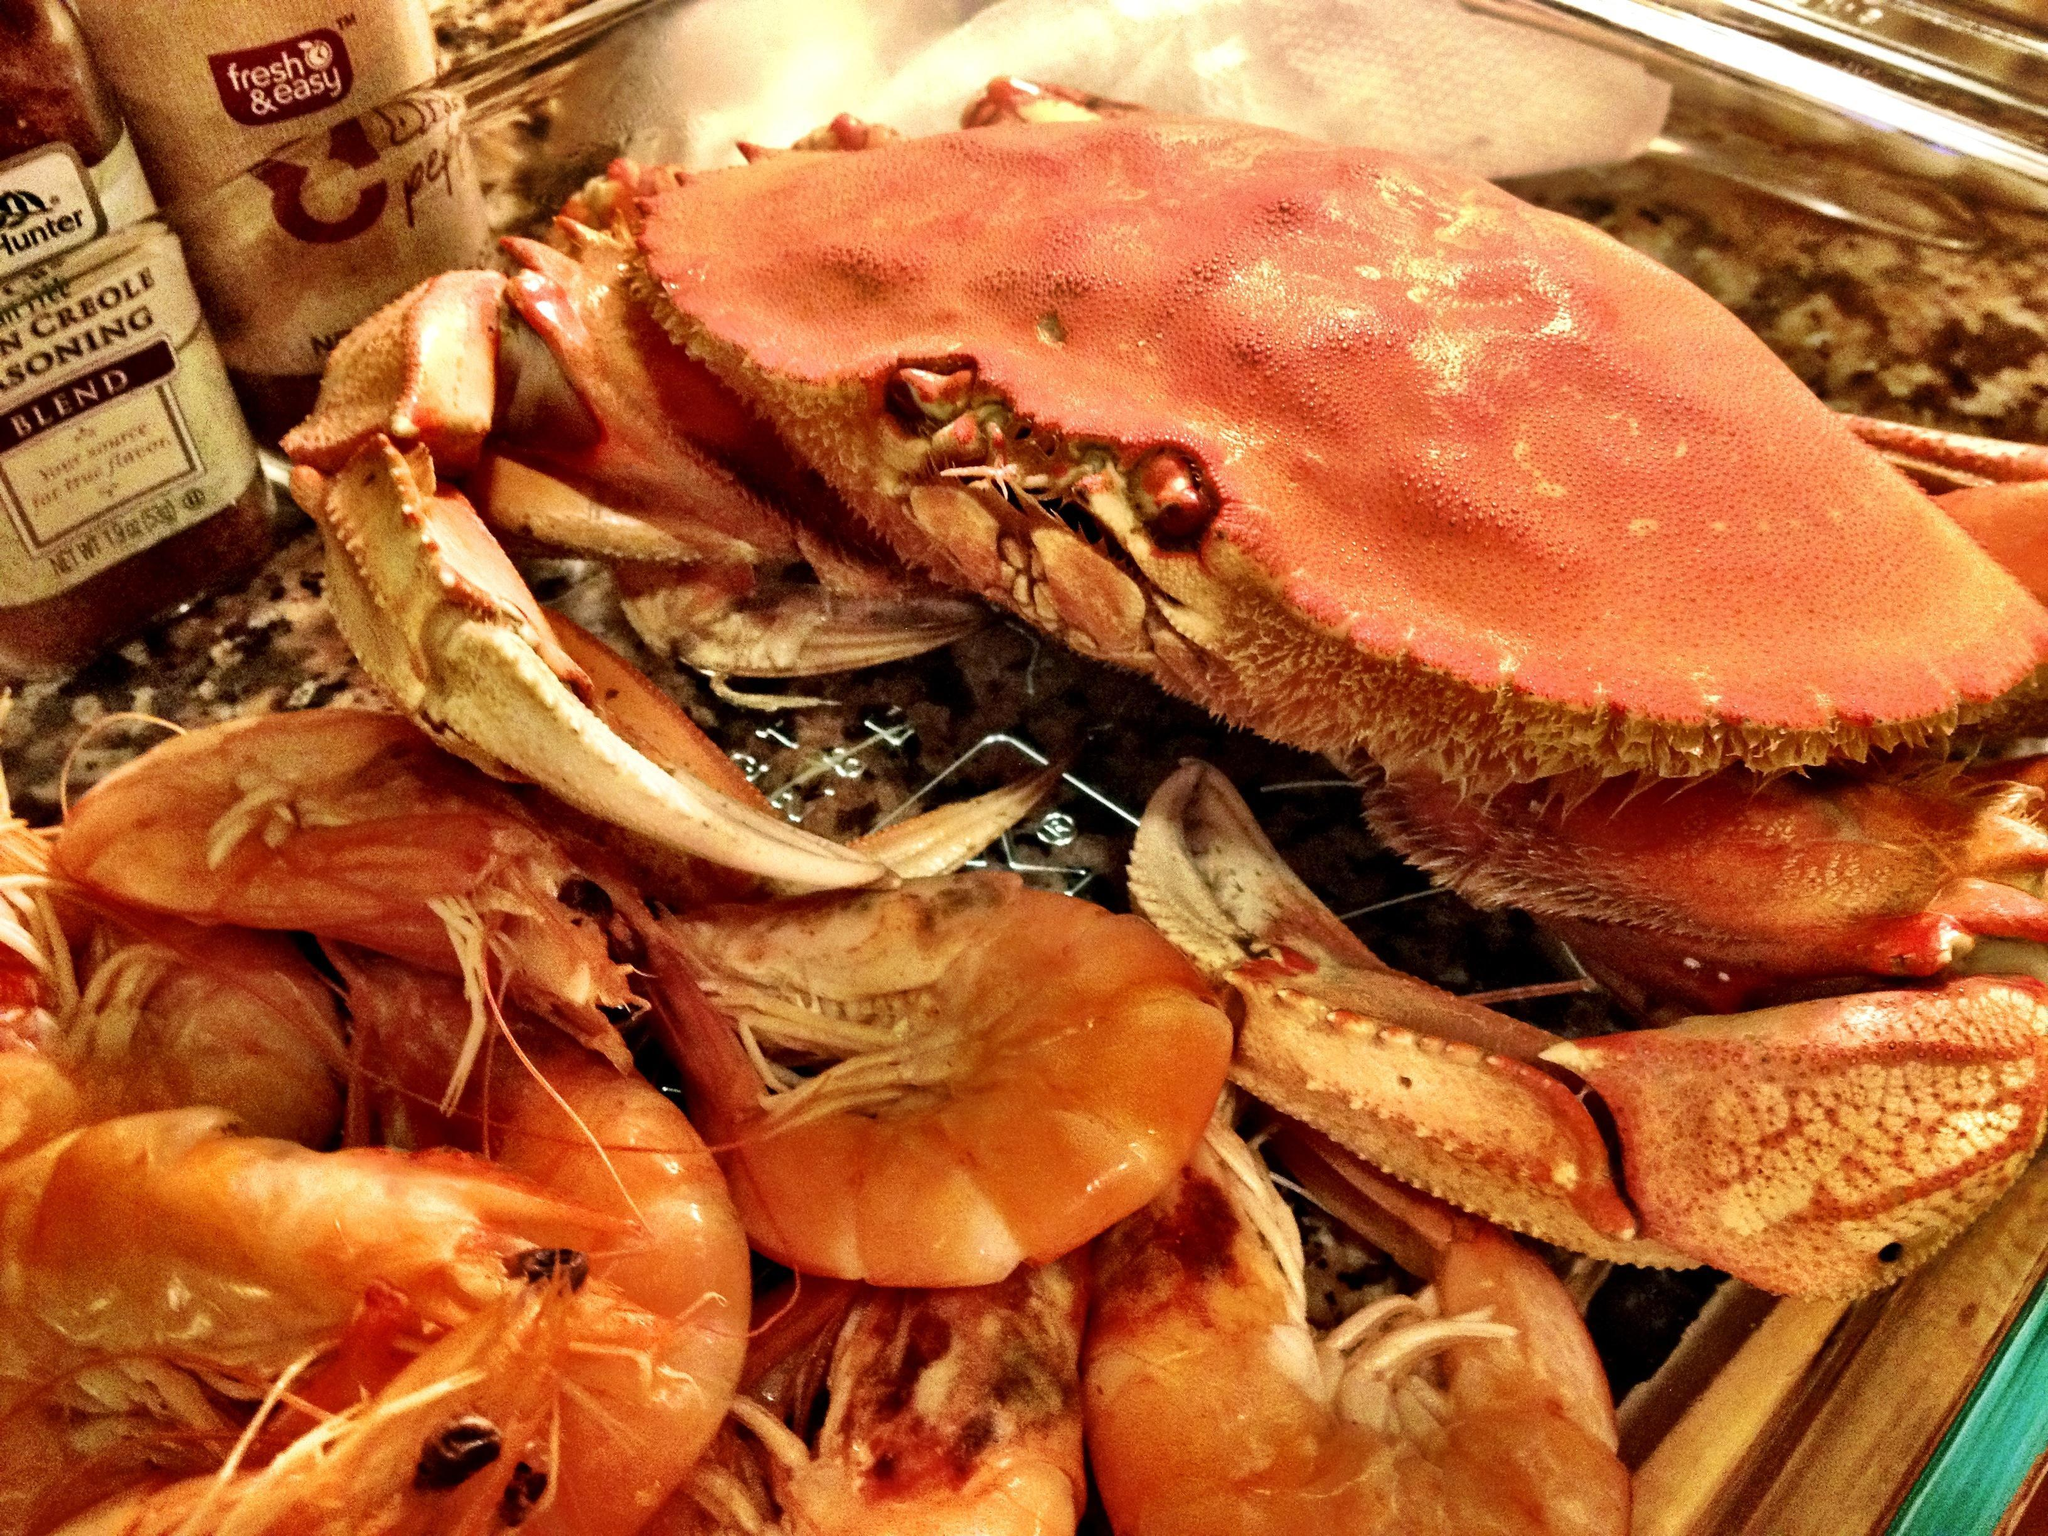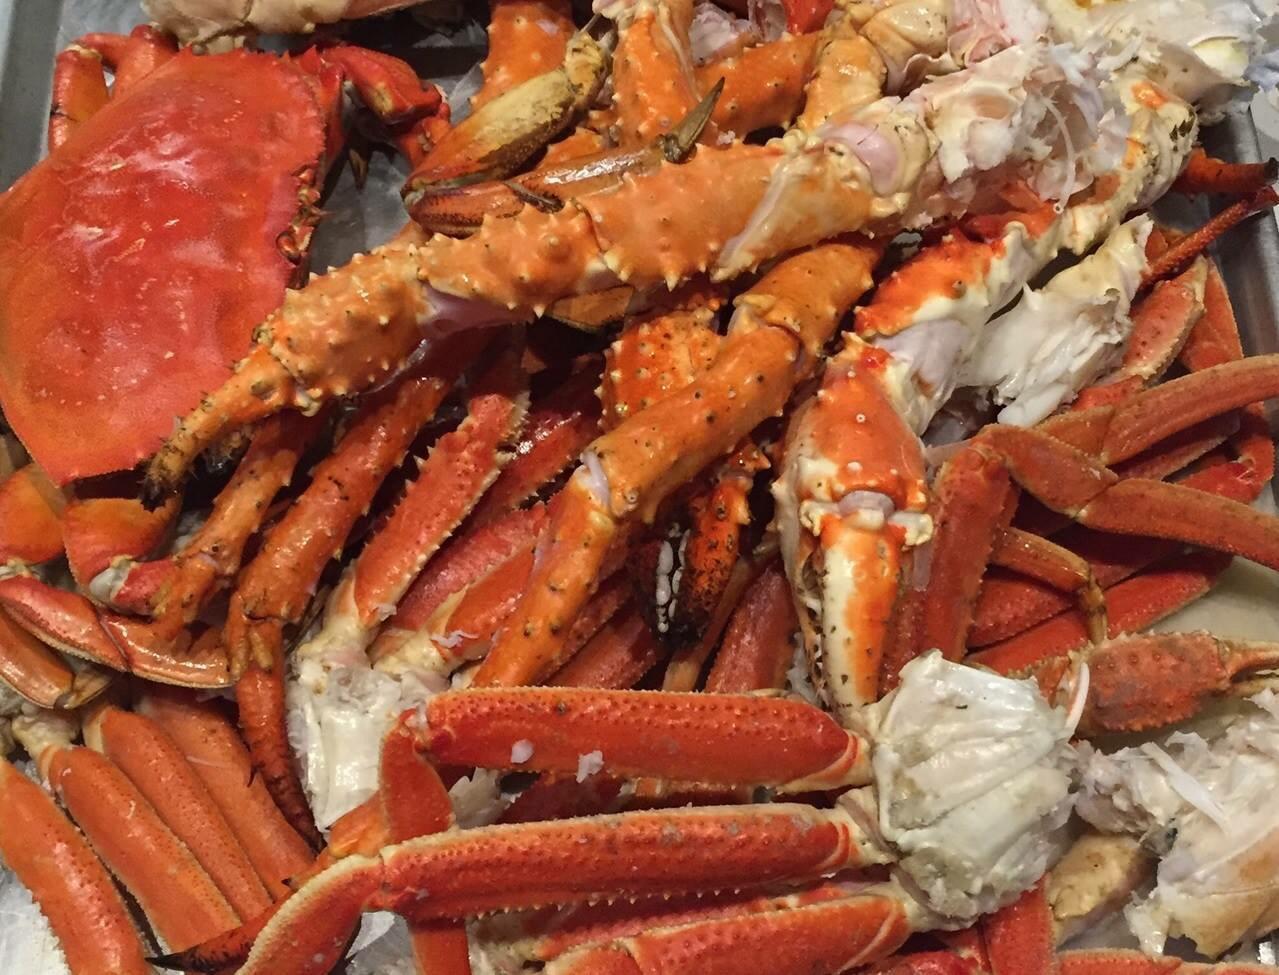The first image is the image on the left, the second image is the image on the right. For the images shown, is this caption "One image includes a camera-facing crab with at least one front claw raised and the edge of a red container behind it." true? Answer yes or no. No. The first image is the image on the left, the second image is the image on the right. For the images shown, is this caption "There are at least 8 upside crabs revealing there what soft part underneath." true? Answer yes or no. No. 